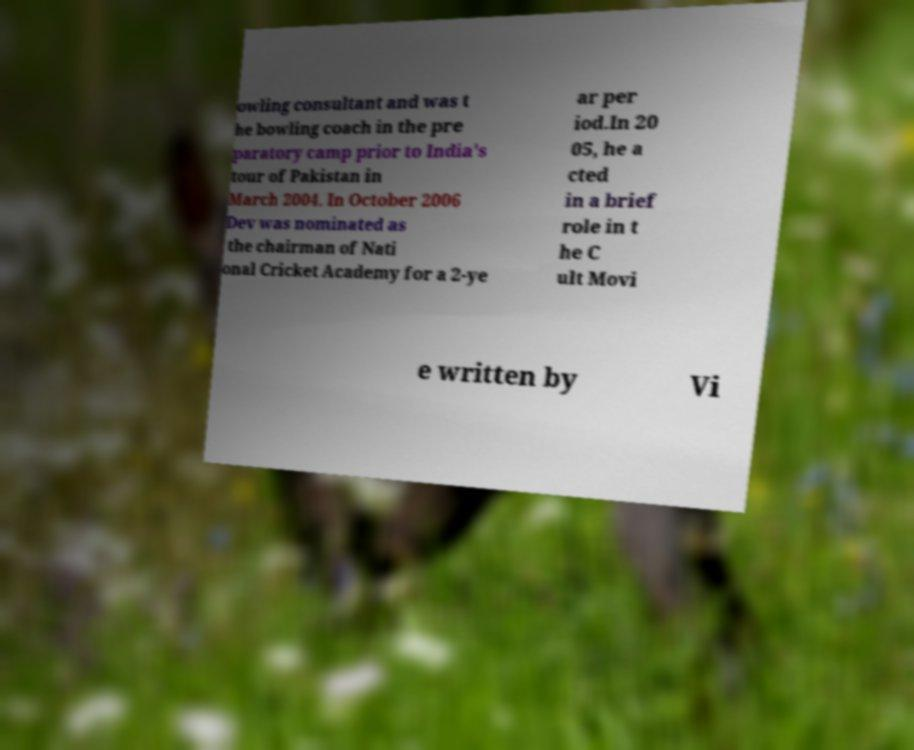What messages or text are displayed in this image? I need them in a readable, typed format. owling consultant and was t he bowling coach in the pre paratory camp prior to India's tour of Pakistan in March 2004. In October 2006 Dev was nominated as the chairman of Nati onal Cricket Academy for a 2-ye ar per iod.In 20 05, he a cted in a brief role in t he C ult Movi e written by Vi 